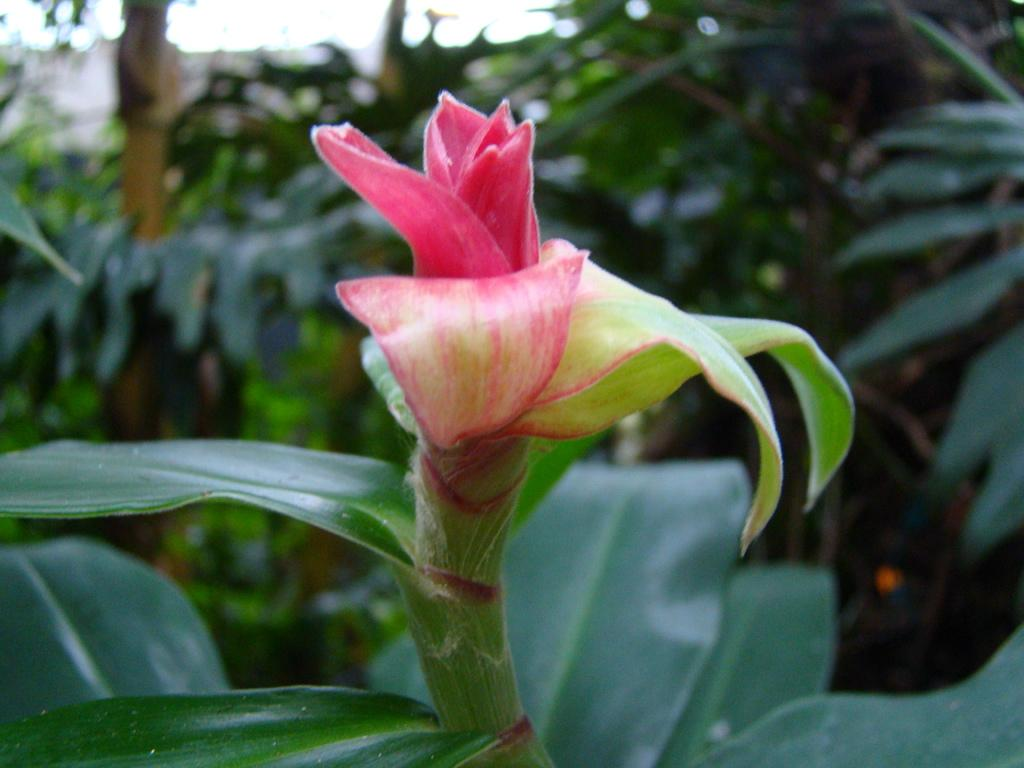What is the main subject of the image? The main subject of the image is a bud. How is the bud connected to the rest of the plant? The bud is connected to a stem. What else can be seen in the image besides the bud and stem? There are plants visible in the image. What is visible at the top of the image? The sky is visible at the top of the image. What type of writing can be seen on the bud in the image? There is no writing present on the bud in the image. How many apples are hanging from the stem in the image? There are no apples present in the image; it features a bud and stem connected to a plant. 